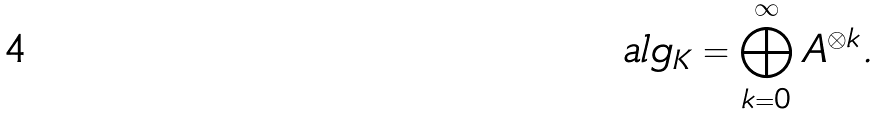Convert formula to latex. <formula><loc_0><loc_0><loc_500><loc_500>\ a l g _ { K } = \bigoplus _ { k = 0 } ^ { \infty } A ^ { \otimes k } .</formula> 